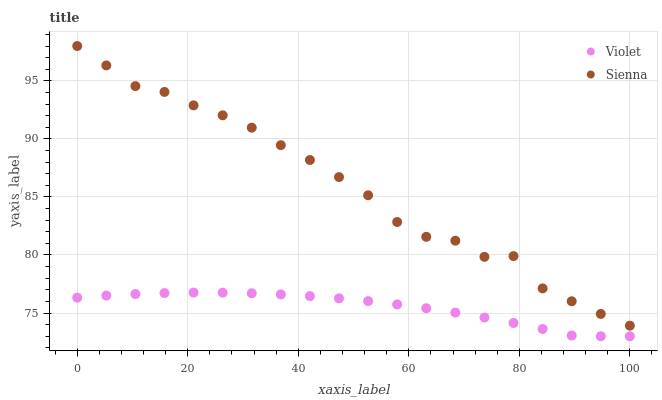Does Violet have the minimum area under the curve?
Answer yes or no. Yes. Does Sienna have the maximum area under the curve?
Answer yes or no. Yes. Does Violet have the maximum area under the curve?
Answer yes or no. No. Is Violet the smoothest?
Answer yes or no. Yes. Is Sienna the roughest?
Answer yes or no. Yes. Is Violet the roughest?
Answer yes or no. No. Does Violet have the lowest value?
Answer yes or no. Yes. Does Sienna have the highest value?
Answer yes or no. Yes. Does Violet have the highest value?
Answer yes or no. No. Is Violet less than Sienna?
Answer yes or no. Yes. Is Sienna greater than Violet?
Answer yes or no. Yes. Does Violet intersect Sienna?
Answer yes or no. No. 